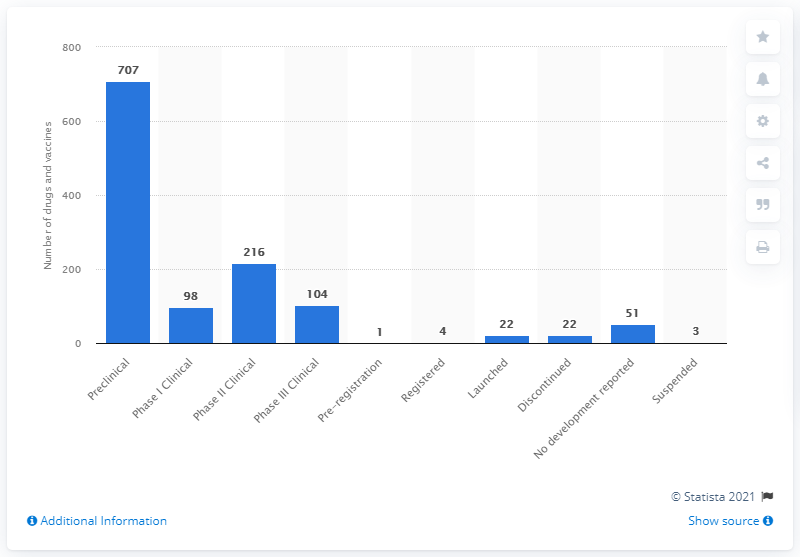Indicate a few pertinent items in this graphic. As of 2020, there were a total of 707 preclinical drugs and vaccines in development. The tallest blue bar in the figure refers to preclinical studies. The total of the bars that are above 200 is 923. 